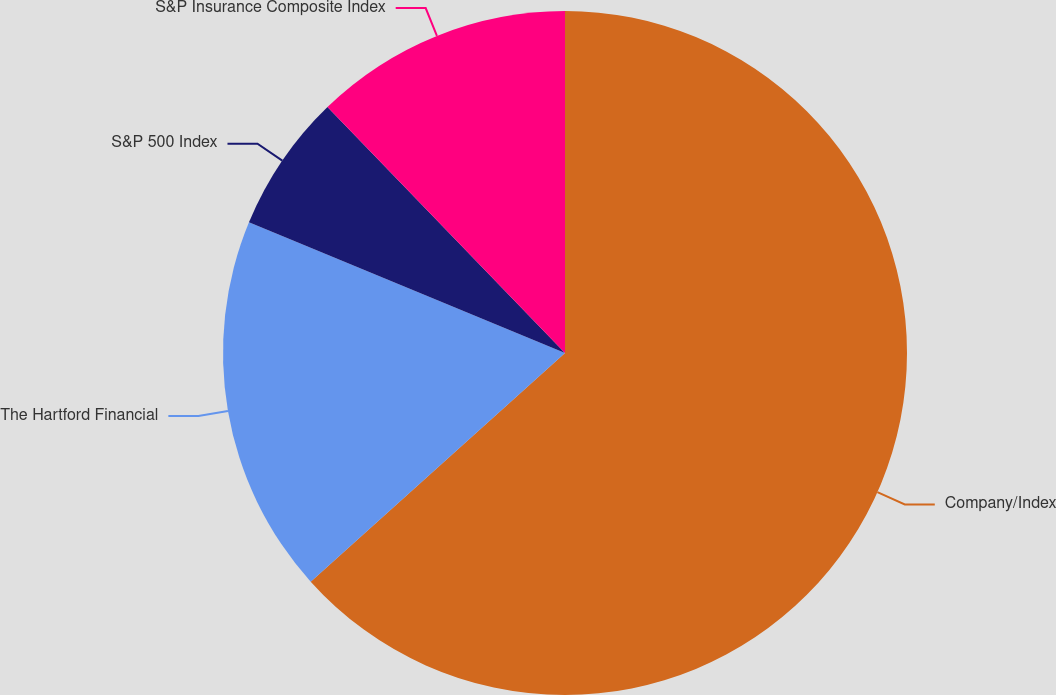Convert chart. <chart><loc_0><loc_0><loc_500><loc_500><pie_chart><fcel>Company/Index<fcel>The Hartford Financial<fcel>S&P 500 Index<fcel>S&P Insurance Composite Index<nl><fcel>63.35%<fcel>17.9%<fcel>6.54%<fcel>12.22%<nl></chart> 